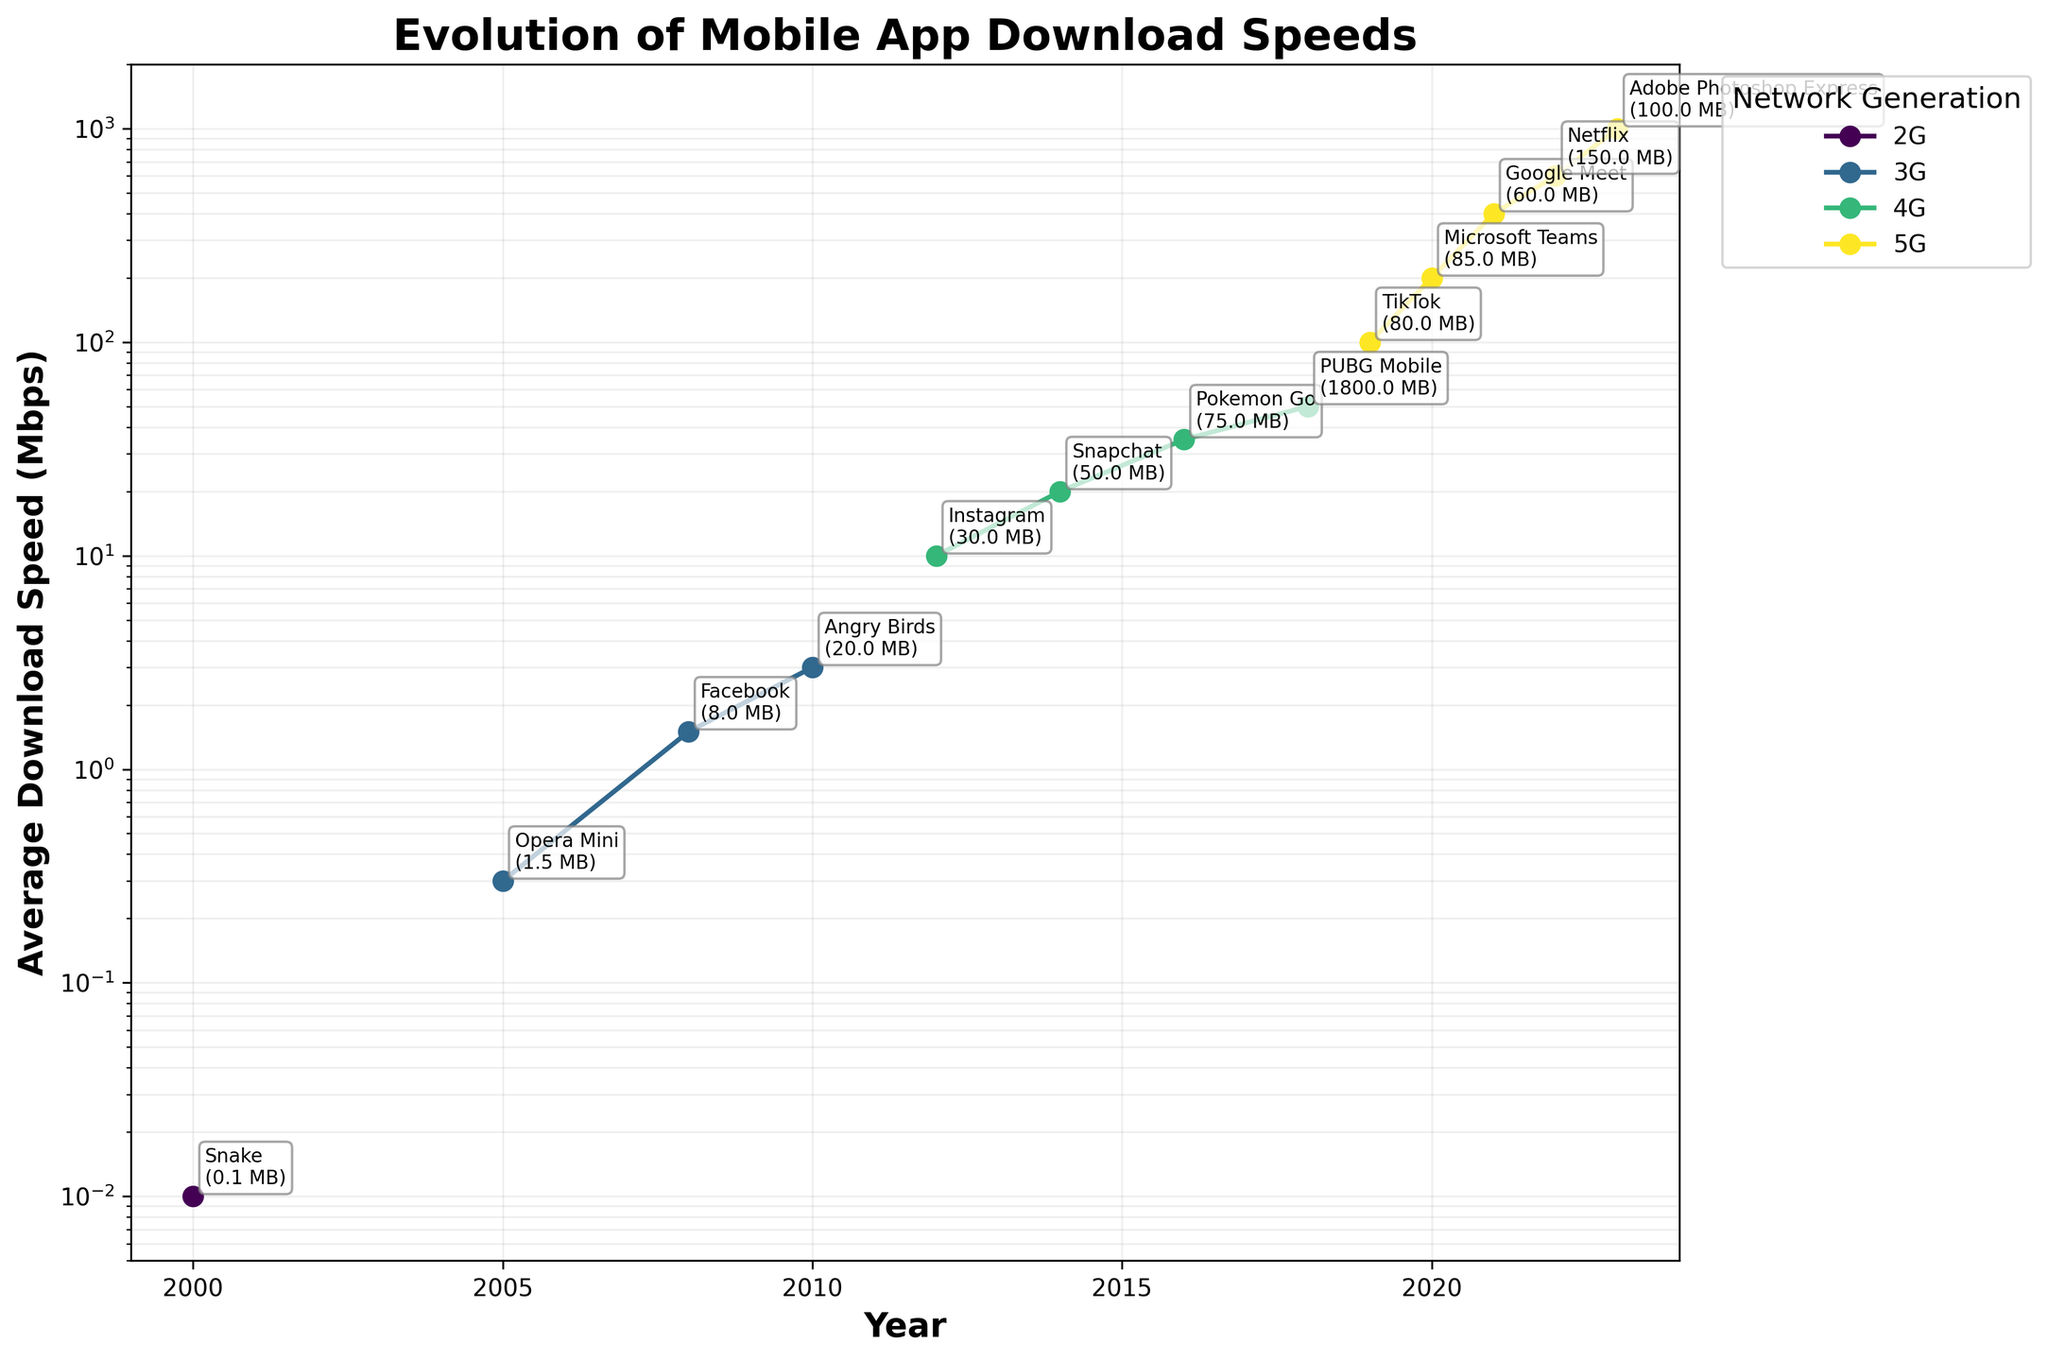What was the download speed improvement from 4G in 2018 to 5G in 2019? The download speed in 2018 with 4G was 50 Mbps, and in 2019 with 5G, it was 100 Mbps. The improvement can be calculated as 100 Mbps - 50 Mbps = 50 Mbps.
Answer: 50 Mbps Which network generation has the highest average download speed, and in which year? The highest average download speed is shown in the graph to be 1000 Mbps, which corresponds to 5G in the year 2023.
Answer: 5G, 2023 How many times faster is the average download speed in 2020 with 5G compared to 2012 with 4G? The download speed in 2020 with 5G is 200 Mbps, and in 2012 with 4G, it is 10 Mbps. The factor of improvement is calculated as 200 Mbps / 10 Mbps = 20 times.
Answer: 20 times What is the average download speed for the 3G network generation over the years represented? The download speeds for 3G are 0.3 Mbps, 1.5 Mbps, and 3 Mbps. The average is calculated as (0.3 + 1.5 + 3) / 3 ≈ 1.6 Mbps.
Answer: 1.6 Mbps In which year did the average download speed for any network generation exceed 30 Mbps for the first time? According to the figure, in 2016 with 4G, the average download speed first exceeded 30 Mbps (35 Mbps).
Answer: 2016 Compare the app sizes for "PUBG Mobile" and "Adobe Photoshop Express" and state which one is larger and by how much? "PUBG Mobile" has a size of 1800 MB, whereas "Adobe Photoshop Express" has a size of 100 MB. The difference in size is 1800 MB - 100 MB = 1700 MB. PUBG Mobile is larger by 1700 MB.
Answer: PUBG Mobile, 1700 MB Which popular Android app corresponds to the year 2005, and what is its size? The app in 2005 is Opera Mini, and its size is 1.5 MB as shown in the figure.
Answer: Opera Mini, 1.5 MB What trend can be observed for the average download speeds from 2000 to 2023? The trend observed is that the average download speeds increase exponentially over time from 0.01 Mbps in 2000 to 1000 Mbps in 2023. This can be seen from the exponentially rising lines plotted in the figure.
Answer: Increasing exponentially Which year marks the first appearance of 5G in the figure, and what is the corresponding popular app? The year 2019 marks the first appearance of 5G, and the corresponding popular app is TikTok.
Answer: 2019, TikTok What is the ratio of average download speeds between the years 2021 and 2010? The average download speed in 2021 with 5G is 400 Mbps, and in 2010 with 3G, it is 3 Mbps. The ratio is 400 Mbps / 3 Mbps ≈ 133.33.
Answer: 133.33 